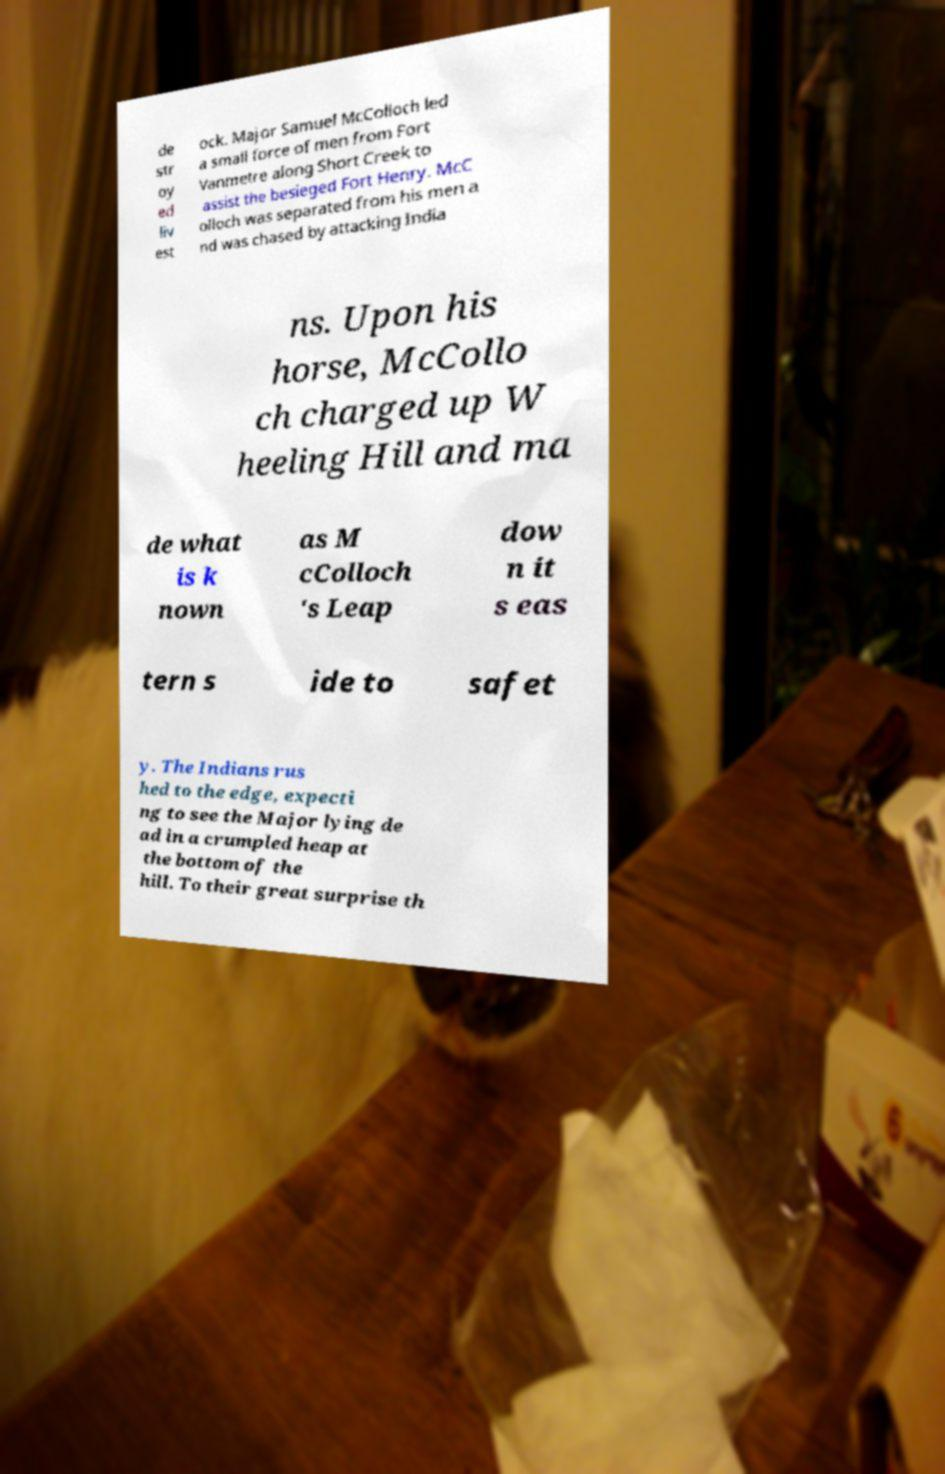Please identify and transcribe the text found in this image. de str oy ed liv est ock. Major Samuel McColloch led a small force of men from Fort Vanmetre along Short Creek to assist the besieged Fort Henry. McC olloch was separated from his men a nd was chased by attacking India ns. Upon his horse, McCollo ch charged up W heeling Hill and ma de what is k nown as M cColloch 's Leap dow n it s eas tern s ide to safet y. The Indians rus hed to the edge, expecti ng to see the Major lying de ad in a crumpled heap at the bottom of the hill. To their great surprise th 